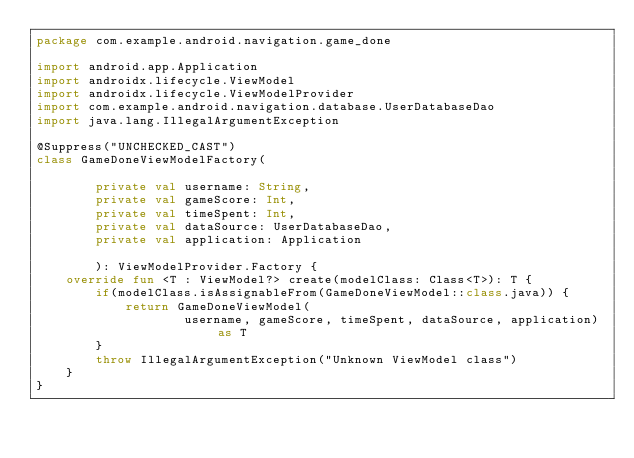Convert code to text. <code><loc_0><loc_0><loc_500><loc_500><_Kotlin_>package com.example.android.navigation.game_done

import android.app.Application
import androidx.lifecycle.ViewModel
import androidx.lifecycle.ViewModelProvider
import com.example.android.navigation.database.UserDatabaseDao
import java.lang.IllegalArgumentException

@Suppress("UNCHECKED_CAST")
class GameDoneViewModelFactory(

        private val username: String,
        private val gameScore: Int,
        private val timeSpent: Int,
        private val dataSource: UserDatabaseDao,
        private val application: Application

        ): ViewModelProvider.Factory {
    override fun <T : ViewModel?> create(modelClass: Class<T>): T {
        if(modelClass.isAssignableFrom(GameDoneViewModel::class.java)) {
            return GameDoneViewModel(
                    username, gameScore, timeSpent, dataSource, application) as T
        }
        throw IllegalArgumentException("Unknown ViewModel class")
    }
}</code> 